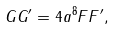<formula> <loc_0><loc_0><loc_500><loc_500>G G ^ { \prime } = 4 a ^ { 8 } F F ^ { \prime } ,</formula> 